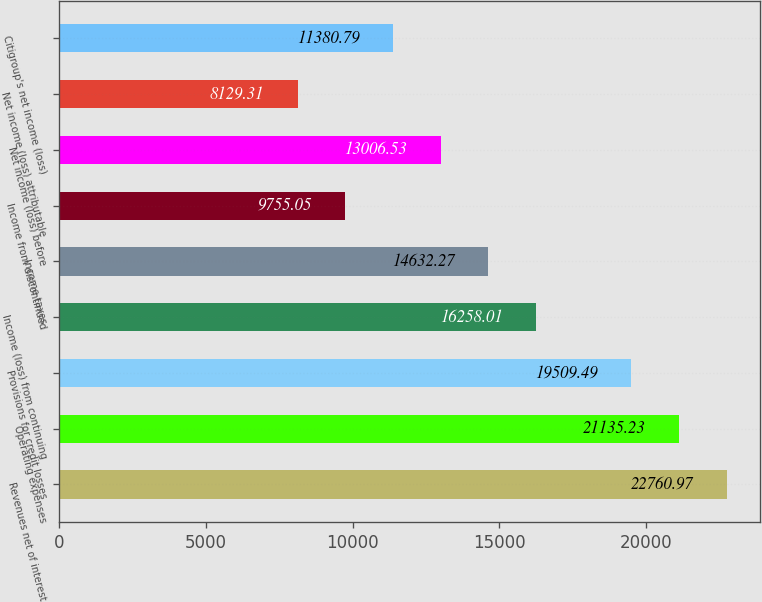<chart> <loc_0><loc_0><loc_500><loc_500><bar_chart><fcel>Revenues net of interest<fcel>Operating expenses<fcel>Provisions for credit losses<fcel>Income (loss) from continuing<fcel>Income taxes<fcel>Income from discontinued<fcel>Net income (loss) before<fcel>Net income (loss) attributable<fcel>Citigroup's net income (loss)<nl><fcel>22761<fcel>21135.2<fcel>19509.5<fcel>16258<fcel>14632.3<fcel>9755.05<fcel>13006.5<fcel>8129.31<fcel>11380.8<nl></chart> 